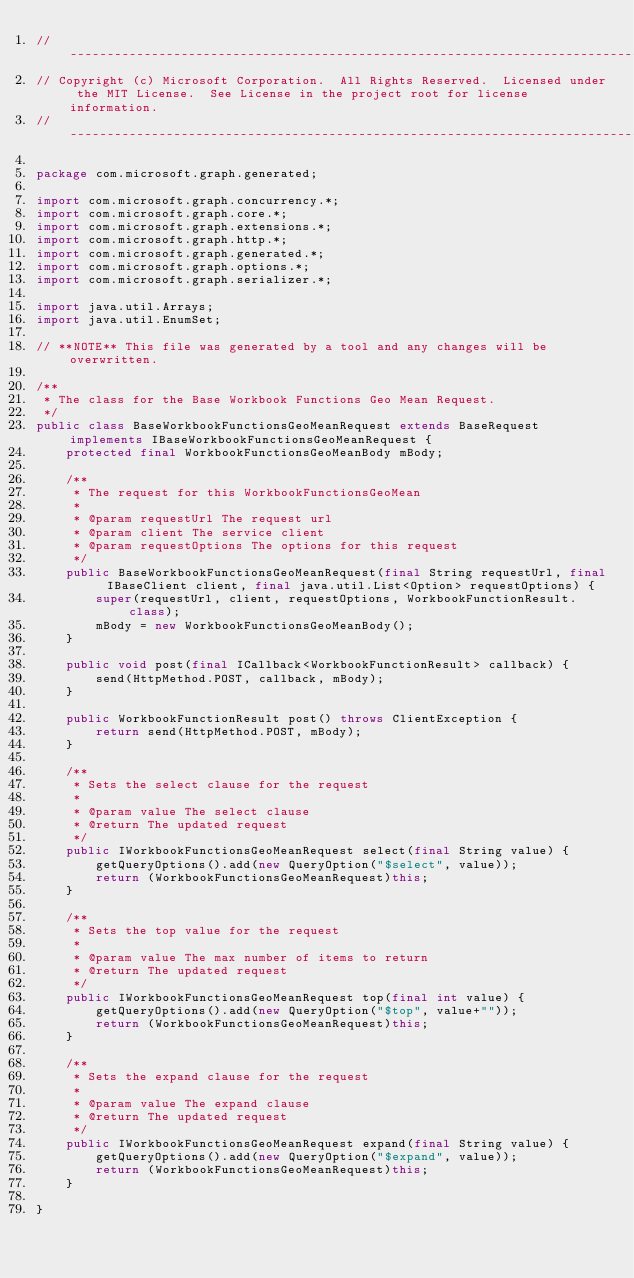<code> <loc_0><loc_0><loc_500><loc_500><_Java_>// ------------------------------------------------------------------------------
// Copyright (c) Microsoft Corporation.  All Rights Reserved.  Licensed under the MIT License.  See License in the project root for license information.
// ------------------------------------------------------------------------------

package com.microsoft.graph.generated;

import com.microsoft.graph.concurrency.*;
import com.microsoft.graph.core.*;
import com.microsoft.graph.extensions.*;
import com.microsoft.graph.http.*;
import com.microsoft.graph.generated.*;
import com.microsoft.graph.options.*;
import com.microsoft.graph.serializer.*;

import java.util.Arrays;
import java.util.EnumSet;

// **NOTE** This file was generated by a tool and any changes will be overwritten.

/**
 * The class for the Base Workbook Functions Geo Mean Request.
 */
public class BaseWorkbookFunctionsGeoMeanRequest extends BaseRequest implements IBaseWorkbookFunctionsGeoMeanRequest {
    protected final WorkbookFunctionsGeoMeanBody mBody;

    /**
     * The request for this WorkbookFunctionsGeoMean
     *
     * @param requestUrl The request url
     * @param client The service client
     * @param requestOptions The options for this request
     */
    public BaseWorkbookFunctionsGeoMeanRequest(final String requestUrl, final IBaseClient client, final java.util.List<Option> requestOptions) {
        super(requestUrl, client, requestOptions, WorkbookFunctionResult.class);
        mBody = new WorkbookFunctionsGeoMeanBody();
    }

    public void post(final ICallback<WorkbookFunctionResult> callback) {
        send(HttpMethod.POST, callback, mBody);
    }

    public WorkbookFunctionResult post() throws ClientException {
        return send(HttpMethod.POST, mBody);
    }

    /**
     * Sets the select clause for the request
     *
     * @param value The select clause
     * @return The updated request
     */
    public IWorkbookFunctionsGeoMeanRequest select(final String value) {
        getQueryOptions().add(new QueryOption("$select", value));
        return (WorkbookFunctionsGeoMeanRequest)this;
    }

    /**
     * Sets the top value for the request
     *
     * @param value The max number of items to return
     * @return The updated request
     */
    public IWorkbookFunctionsGeoMeanRequest top(final int value) {
        getQueryOptions().add(new QueryOption("$top", value+""));
        return (WorkbookFunctionsGeoMeanRequest)this;
    }

    /**
     * Sets the expand clause for the request
     *
     * @param value The expand clause
     * @return The updated request
     */
    public IWorkbookFunctionsGeoMeanRequest expand(final String value) {
        getQueryOptions().add(new QueryOption("$expand", value));
        return (WorkbookFunctionsGeoMeanRequest)this;
    }

}
</code> 